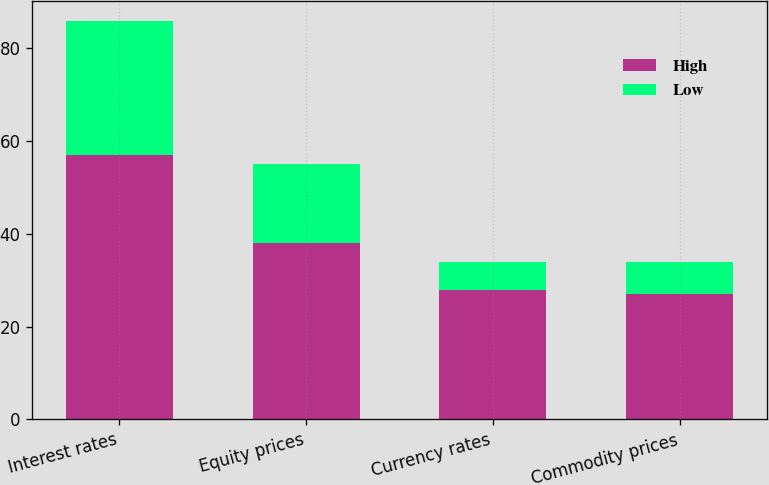Convert chart to OTSL. <chart><loc_0><loc_0><loc_500><loc_500><stacked_bar_chart><ecel><fcel>Interest rates<fcel>Equity prices<fcel>Currency rates<fcel>Commodity prices<nl><fcel>High<fcel>57<fcel>38<fcel>28<fcel>27<nl><fcel>Low<fcel>29<fcel>17<fcel>6<fcel>7<nl></chart> 